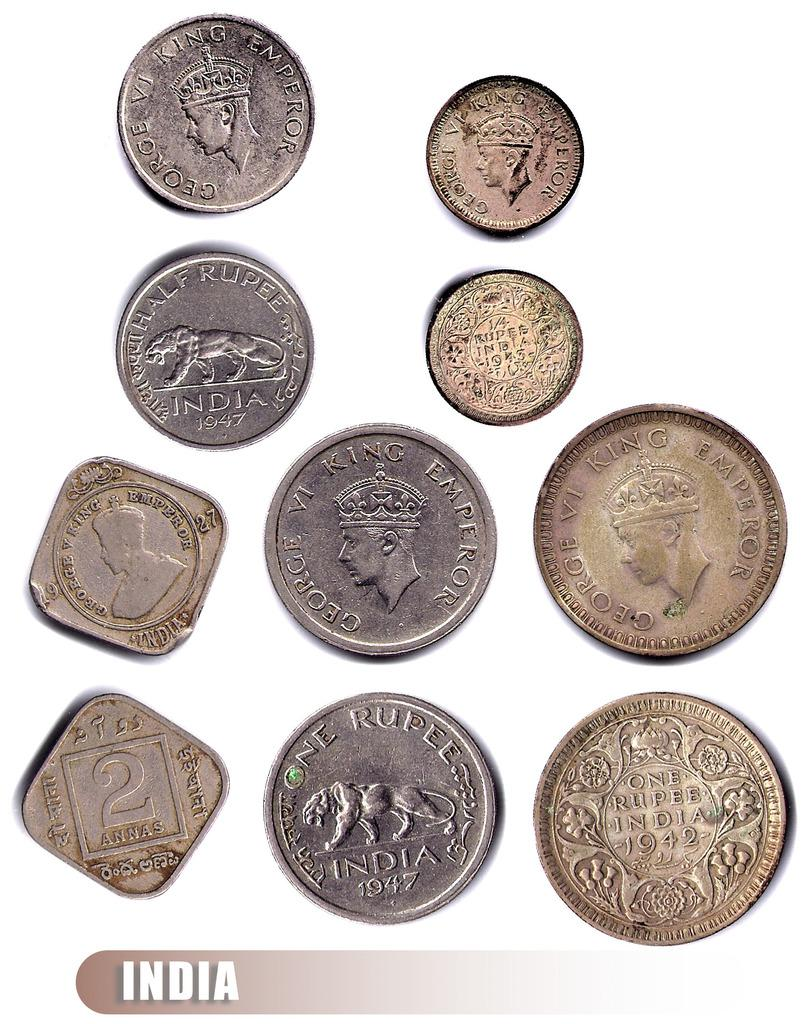Provide a one-sentence caption for the provided image. A collection of coins from India, many with the word India and their denomination on them. 